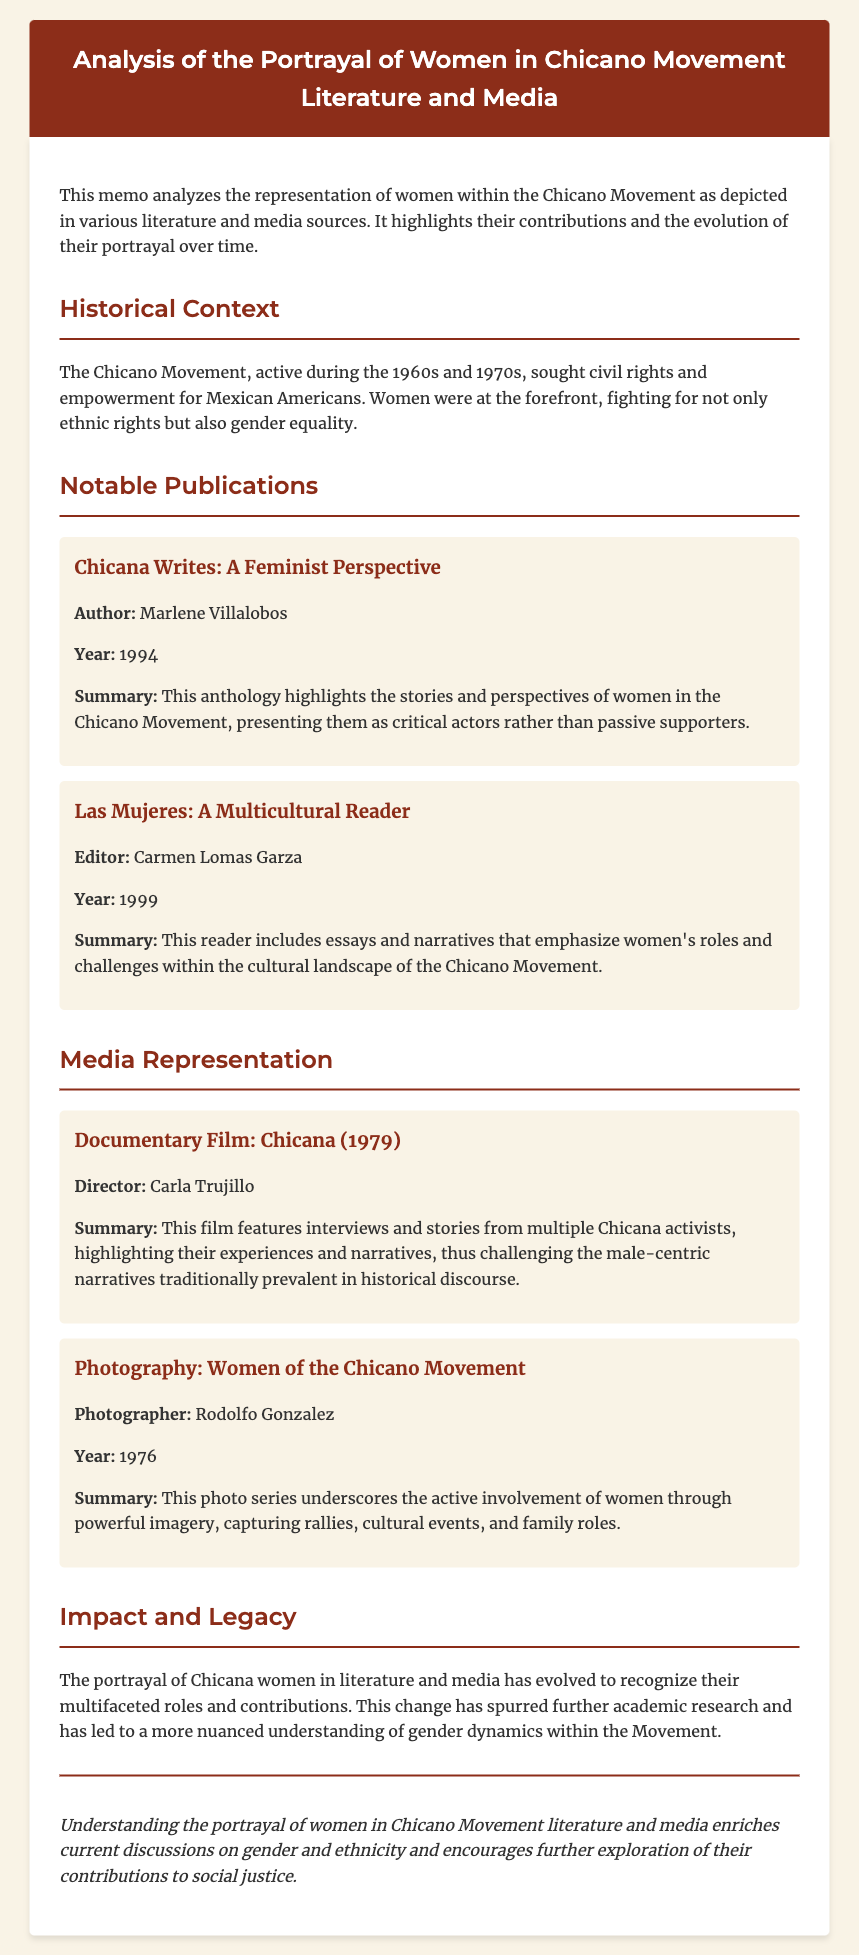What is the title of the memo? The title is explicitly stated in the header of the document, which is "Analysis of the Portrayal of Women in Chicano Movement Literature and Media."
Answer: Analysis of the Portrayal of Women in Chicano Movement Literature and Media Who is the author of "Chicana Writes: A Feminist Perspective"? The document provides the author's name under the publication titled "Chicana Writes: A Feminist Perspective," which is Marlene Villalobos.
Answer: Marlene Villalobos In what year was "Las Mujeres: A Multicultural Reader" published? The publication year for "Las Mujeres: A Multicultural Reader" is given in the document, which is 1999.
Answer: 1999 What type of media is "Chicana (1979)"? The document specifies that "Chicana (1979)" is a documentary film.
Answer: Documentary Film What is a significant focus of the documentary "Chicana (1979)"? The summary in the document mentions that the film highlights Chicana activists' experiences and narratives, emphasizing their roles contrary to male-centric narratives.
Answer: Experiences and narratives of Chicana activists How did the portrayal of Chicana women evolve according to the memo? The memo discusses the evolution as a recognition of their multifaceted roles and contributions within the movement, indicating a shift from passive to active representation.
Answer: Multifaceted roles and contributions What does the photography series "Women of the Chicano Movement" capture? The summary states that this photo series captures rallies, cultural events, and family roles, underscoring the active involvement of women.
Answer: Rallies, cultural events, and family roles What is mentioned as a consequence of acknowledging women's contributions in the Chicano Movement? The document states that this change has encouraged further academic research and nuanced understanding of gender dynamics.
Answer: Further academic research What is the main conclusion of the memo? The conclusion in the document emphasizes that understanding the portrayal of women enriches discussions on gender and ethnicity, encouraging exploration of their contributions to social justice.
Answer: Enriches discussions on gender and ethnicity 